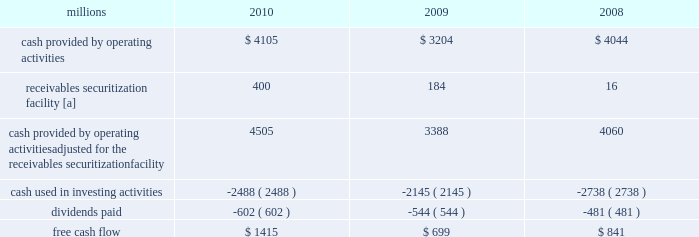2009 levels , we returned a portion of these assets to active service .
At the end of 2010 , we continued to maintain in storage approximately 17% ( 17 % ) of our multiple purpose locomotives and 14% ( 14 % ) of our freight car inventory , reflecting our ability to effectively leverage our assets as volumes return to our network .
2022 fuel prices 2013 fuel prices generally increased throughout 2010 as the economy improved .
Our average diesel fuel price per gallon increased nearly 20% ( 20 % ) from january to december of 2010 , driven by higher crude oil barrel prices and conversion spreads .
Compared to 2009 , our diesel fuel price per gallon consumed increased 31% ( 31 % ) , driving operating expenses up by $ 566 million ( excluding any impact from year-over-year volume increases ) .
To partially offset the effect of higher fuel prices , we reduced our consumption rate by 3% ( 3 % ) during the year , saving approximately 27 million gallons of fuel .
The use of newer , more fuel efficient locomotives ; increased use of distributed locomotive power ( the practice of distributing locomotives throughout a train rather than positioning them all in the lead resulting in safer and more efficient train operations ) ; fuel conservation programs ; and efficient network operations and asset utilization all contributed to this improvement .
2022 free cash flow 2013 cash generated by operating activities ( adjusted for the reclassification of our receivables securitization facility ) totaled $ 4.5 billion , yielding record free cash flow of $ 1.4 billion in 2010 .
Free cash flow is defined as cash provided by operating activities ( adjusted for the reclassification of our receivables securitization facility ) , less cash used in investing activities and dividends paid .
Free cash flow is not considered a financial measure under accounting principles generally accepted in the u.s .
( gaap ) by sec regulation g and item 10 of sec regulation s-k .
We believe free cash flow is important in evaluating our financial performance and measures our ability to generate cash without additional external financings .
Free cash flow should be considered in addition to , rather than as a substitute for , cash provided by operating activities .
The table reconciles cash provided by operating activities ( gaap measure ) to free cash flow ( non-gaap measure ) : millions 2010 2009 2008 .
[a] effective january 1 , 2010 , a new accounting standard required us to account for receivables transferred under our receivables securitization facility as secured borrowings in our consolidated statements of financial position and as financing activities in our consolidated statements of cash flows .
The receivables securitization facility is included in our free cash flow calculation to adjust cash provided by operating activities as though our receivables securitization facility had been accounted for under the new accounting standard for all periods presented .
2011 outlook 2022 safety 2013 operating a safe railroad benefits our employees , our customers , our shareholders , and the public .
We will continue using a multi-faceted approach to safety , utilizing technology , risk assessment , quality control , and training , and engaging our employees .
We will continue implementing total safety culture ( tsc ) throughout our operations .
Tsc is designed to establish , maintain , reinforce , and promote safe practices among co-workers .
This process allows us to identify and implement best practices for employee and operational safety .
Reducing grade crossing incidents is a critical aspect of our safety programs , and we will continue our efforts to maintain and close crossings ; install video cameras on locomotives ; and educate the public and law enforcement agencies about crossing safety through a combination of our own programs ( including risk assessment strategies ) , various industry programs , and engaging local communities .
2022 transportation plan 2013 to build upon our success in recent years , we will continue evaluating traffic flows and network logistic patterns , which can be quite dynamic , to identify additional opportunities to simplify operations , remove network variability , and improve network efficiency and asset utilization .
We plan to adjust manpower and our locomotive and rail car fleets to meet customer needs and put .
In 2010 what was the ratio of the cash generated by operating activities to the free cash flow of $ 1.4 billion in 2010 .? 
Computations: (4.5 / 1.4)
Answer: 3.21429. 